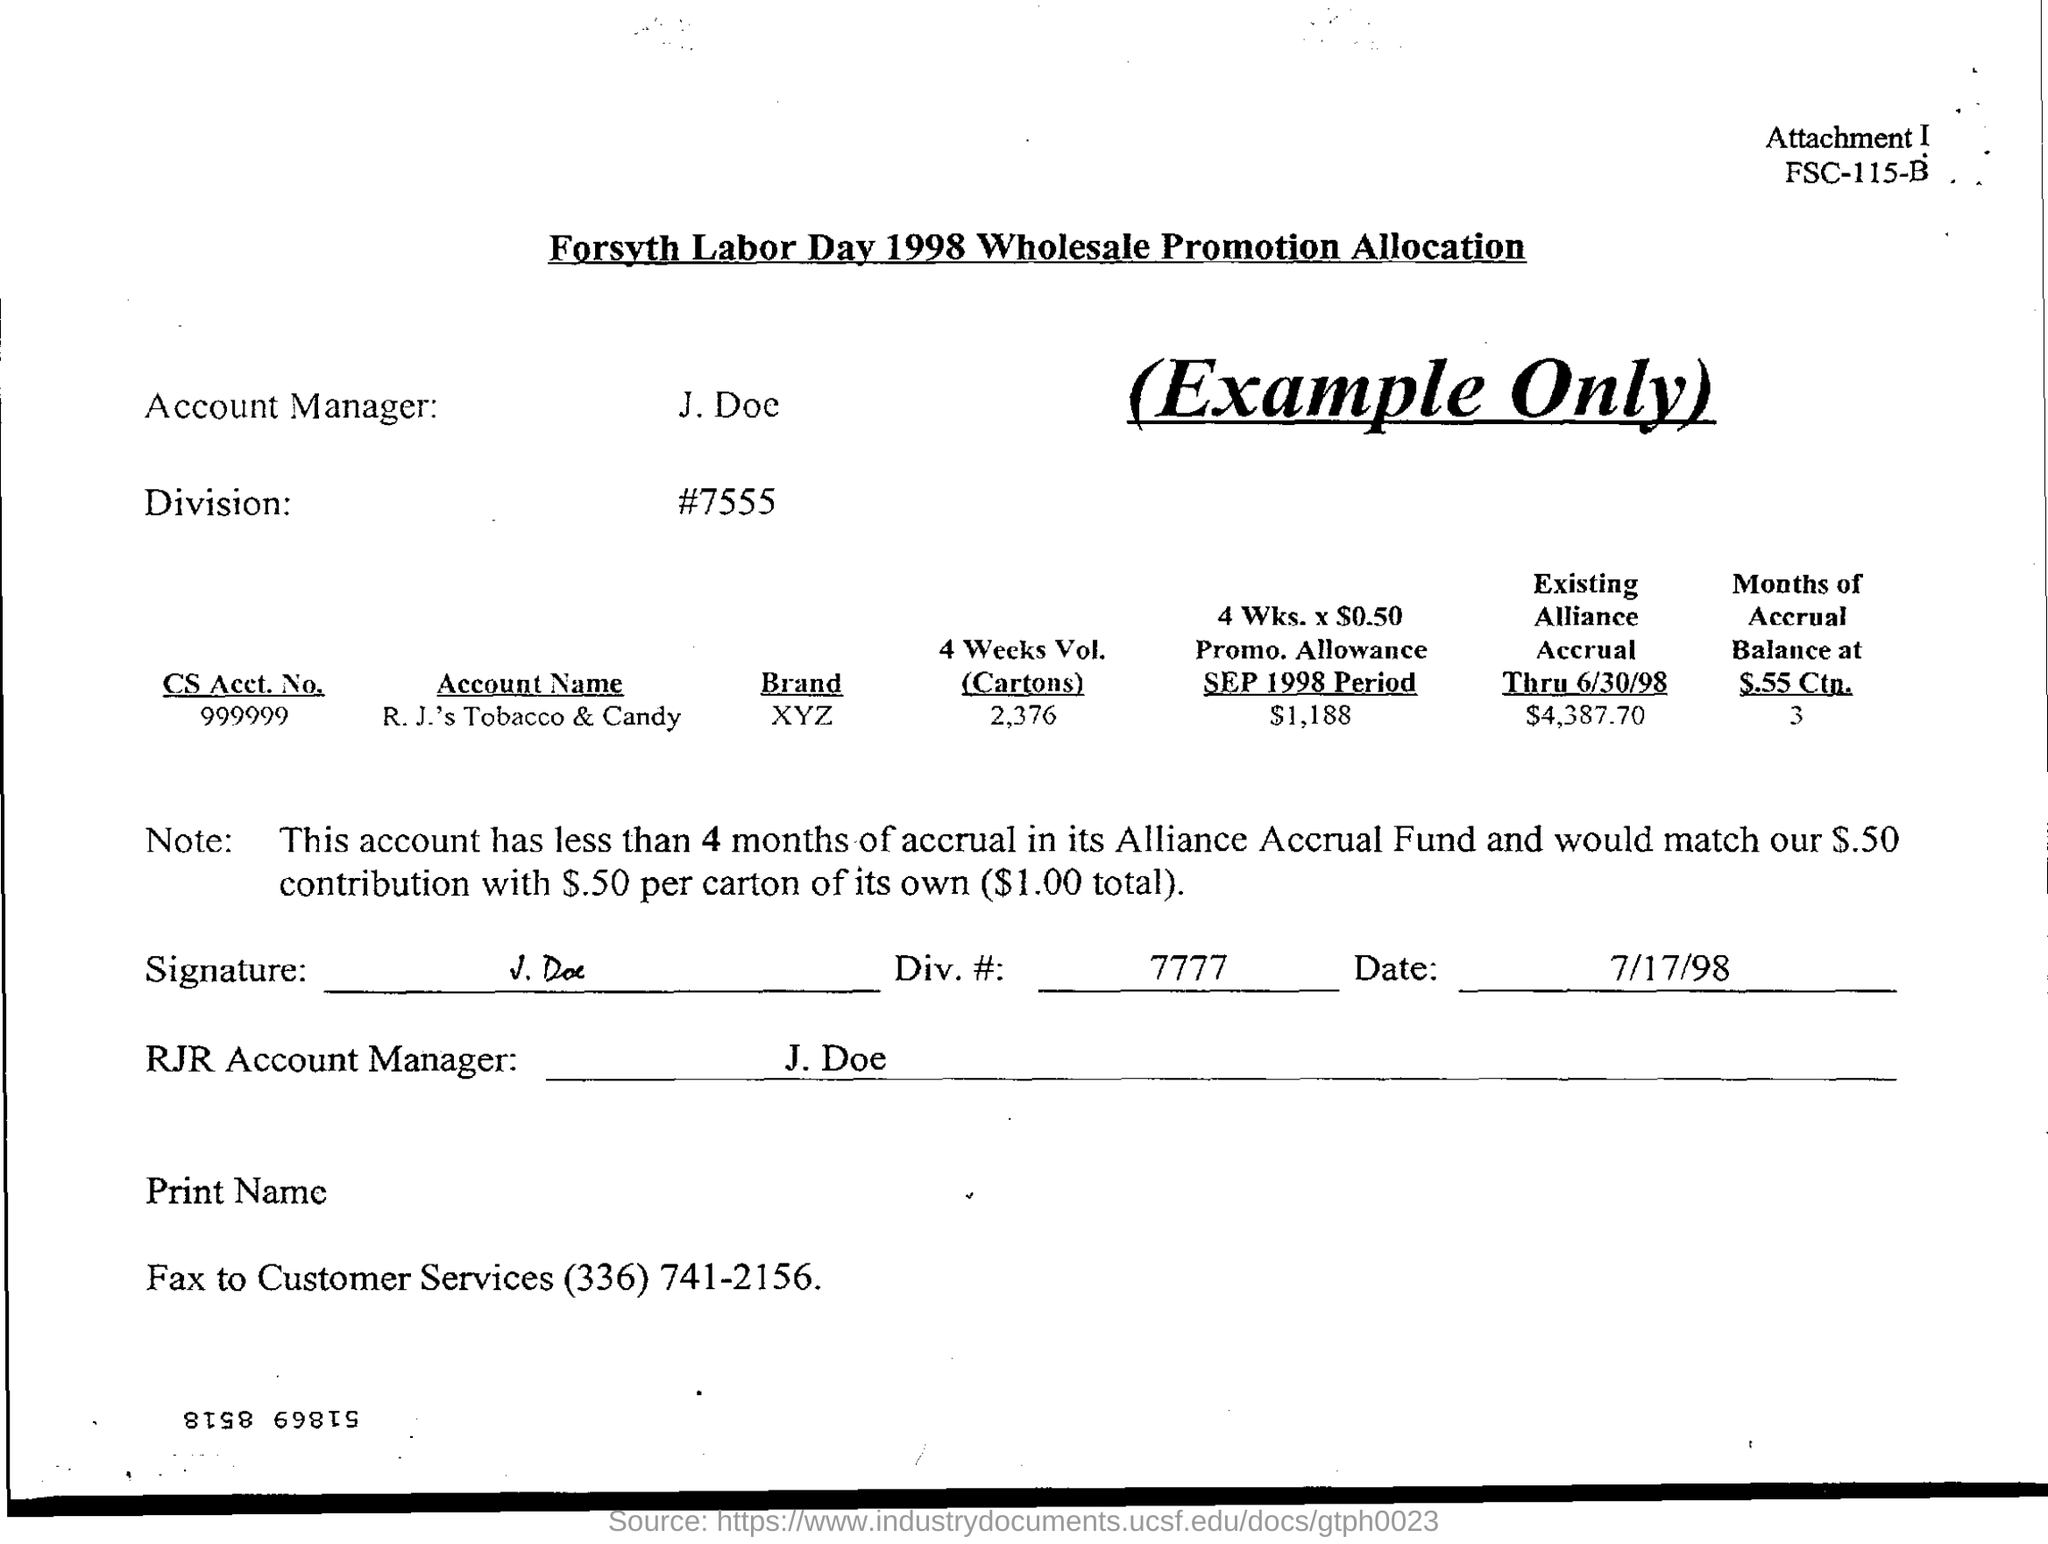Who is the account manager?
Give a very brief answer. J. Doe. What is the 4 Weeks Vol. (Cartons) ?
Provide a succinct answer. 2376. 